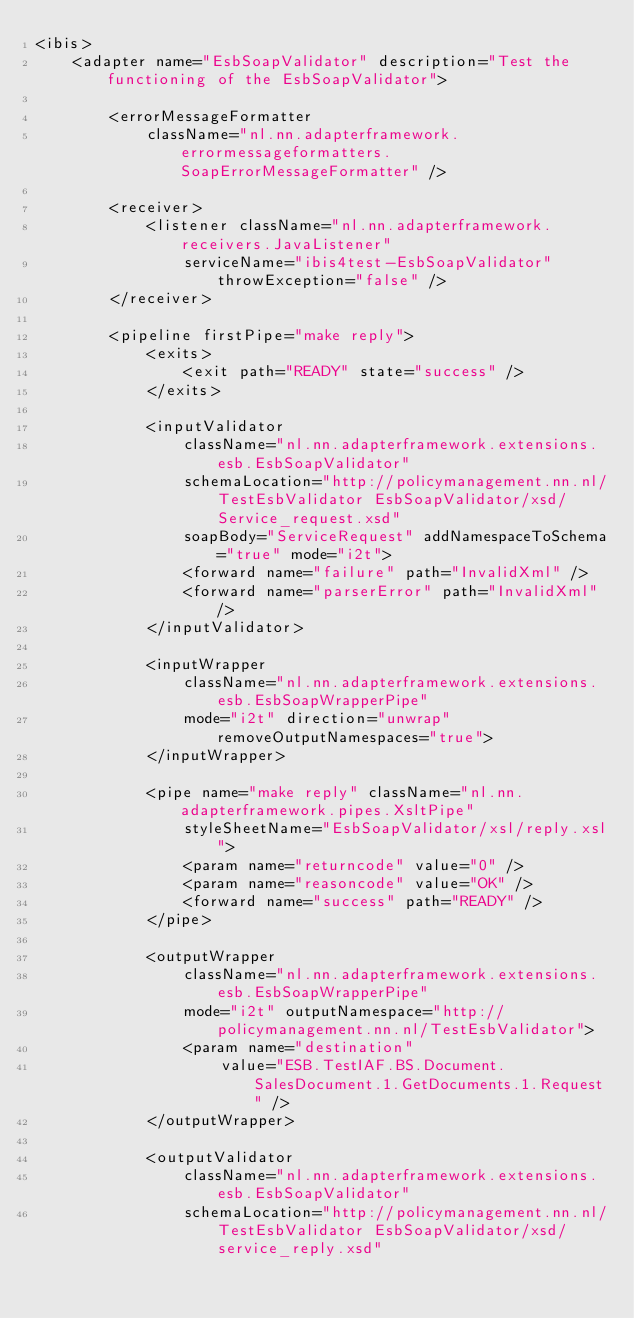<code> <loc_0><loc_0><loc_500><loc_500><_XML_><ibis>
	<adapter name="EsbSoapValidator" description="Test the functioning of the EsbSoapValidator">

		<errorMessageFormatter
			className="nl.nn.adapterframework.errormessageformatters.SoapErrorMessageFormatter" />

		<receiver>
			<listener className="nl.nn.adapterframework.receivers.JavaListener"
				serviceName="ibis4test-EsbSoapValidator" throwException="false" />
		</receiver>

		<pipeline firstPipe="make reply">
			<exits>
				<exit path="READY" state="success" />
			</exits>

			<inputValidator
				className="nl.nn.adapterframework.extensions.esb.EsbSoapValidator"
				schemaLocation="http://policymanagement.nn.nl/TestEsbValidator EsbSoapValidator/xsd/Service_request.xsd"
				soapBody="ServiceRequest" addNamespaceToSchema="true" mode="i2t">
				<forward name="failure" path="InvalidXml" />
				<forward name="parserError" path="InvalidXml" />
			</inputValidator>

			<inputWrapper
				className="nl.nn.adapterframework.extensions.esb.EsbSoapWrapperPipe"
				mode="i2t" direction="unwrap" removeOutputNamespaces="true">
			</inputWrapper>

			<pipe name="make reply" className="nl.nn.adapterframework.pipes.XsltPipe"
				styleSheetName="EsbSoapValidator/xsl/reply.xsl">
				<param name="returncode" value="0" />
				<param name="reasoncode" value="OK" />
				<forward name="success" path="READY" />
			</pipe>

			<outputWrapper
				className="nl.nn.adapterframework.extensions.esb.EsbSoapWrapperPipe"
				mode="i2t" outputNamespace="http://policymanagement.nn.nl/TestEsbValidator">
				<param name="destination"
					value="ESB.TestIAF.BS.Document.SalesDocument.1.GetDocuments.1.Request" />
			</outputWrapper>

			<outputValidator
				className="nl.nn.adapterframework.extensions.esb.EsbSoapValidator"
				schemaLocation="http://policymanagement.nn.nl/TestEsbValidator EsbSoapValidator/xsd/service_reply.xsd"</code> 